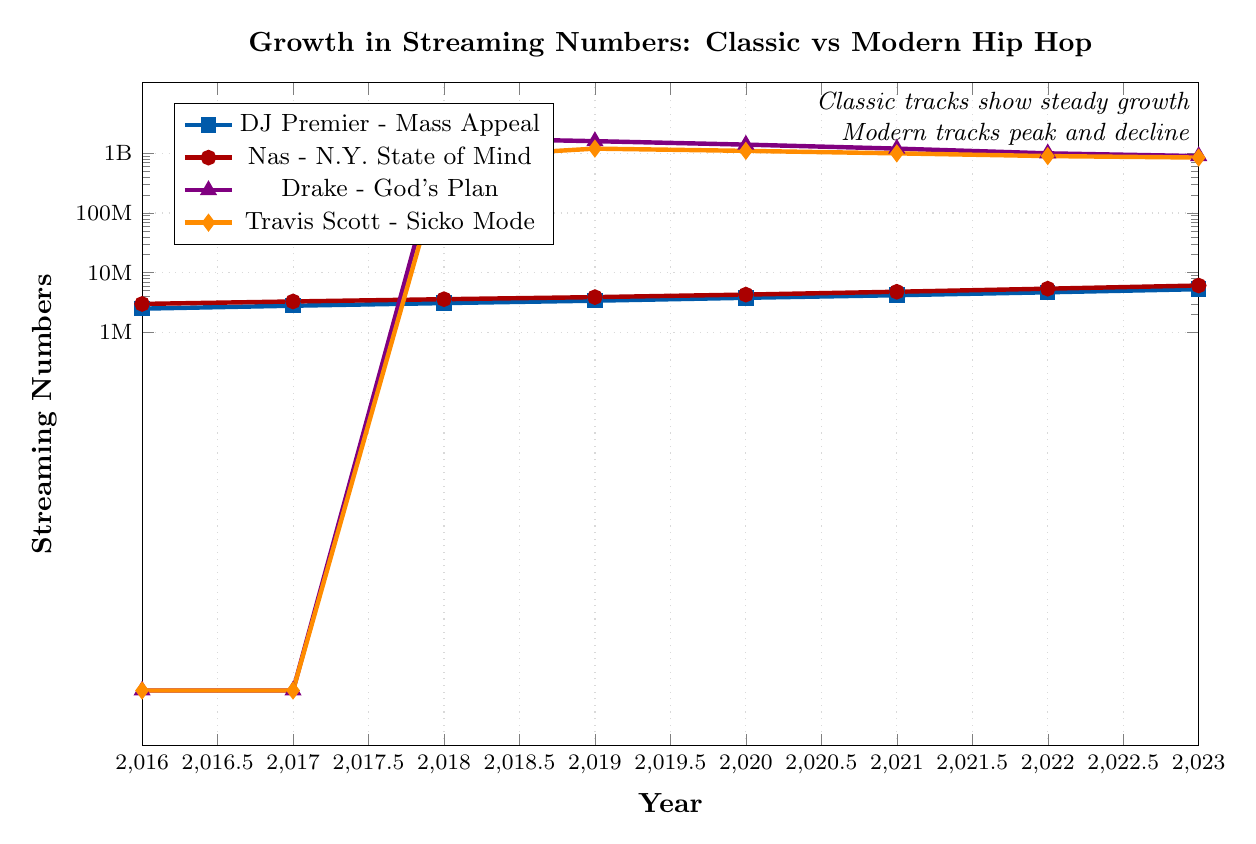What's the overall trend in streaming numbers for DJ Premier's "Mass Appeal" from 2016 to 2023? The figure shows a steadily increasing trend in the streaming numbers for "Mass Appeal" each year. The numbers start from 2,500,000 in 2016 and gradually increase to 5,300,000 by 2023.
Answer: Steady increase How do the streaming numbers for Nas's "N.Y. State of Mind" in 2023 compare to 2016? In 2016, the streaming numbers for "N.Y. State of Mind" were 3,000,000, while in 2023 they increased to 6,100,000. To compare, the numbers grew by 3,100,000 over this period.
Answer: Increased by 3,100,000 Which track had the highest streaming numbers in 2018, and what were they? In 2018, "God's Plan" by Drake had the highest streaming numbers, with 1,800,000,000 streams.
Answer: God's Plan by Drake with 1,800,000,000 streams Between 2018 and 2023, by how much did the streaming numbers for Travis Scott’s "Sicko Mode" decline? In 2018, "Sicko Mode" had 850,000,000 streams, and by 2023, it had 850,000,000 streams. The streaming numbers remained the same in 2018 and 2023.
Answer: Did not change Compare the growth trends of classic tracks (DJ Premier and Nas) and modern tracks (Drake and Travis Scott) between 2018 and 2023. What difference do you observe? Classic tracks show a steady increase in streaming numbers, with DJ Premier's numbers growing from 3,100,000 to 5,300,000 and Nas's from 3,600,000 to 6,100,000. Meanwhile, modern tracks show a decline over the same period, with Drake’s numbers dropping from 1,800,000,000 to 900,000,000 and Travis Scott’s from 850,000,000 to 850,000,000.
Answer: Classic tracks grow steadily, modern tracks decline By how much did "Nas - N.Y. State of Mind" streaming numbers increase each year on average from 2016 to 2023? The increase from 2016 to 2023 for "N.Y. State of Mind" is 3,100,000 (from 3,000,000 to 6,100,000). Dividing this by 7 years, the average annual increase is \( \frac{3,100,000}{7} \approx 442,857 \).
Answer: Approx. 442,857 Which track had the most significant drop in streaming numbers from 2018 to 2023? From the figure, "God's Plan" by Drake had the most significant drop, decreasing from 1,800,000,000 in 2018 to 900,000,000 in 2023.
Answer: God's Plan by Drake Rank the tracks in terms of their streaming numbers in 2023 from highest to lowest. In 2023, the streaming numbers are: Nas - 6,100,000, DJ Premier - 5,300,000, Drake - 900,000,000, and Travis Scott - 850,000,000. Ranking them gives: 1. Nas, 2. DJ Premier, 3. Drake, 4. Travis Scott.
Answer: 1. Nas, 2. DJ Premier, 3. Drake, 4. Travis Scott Compare the lowest streaming numbers observed for each track and identify which track holds the lowest value overall. In the figure, DJ Premier's "Mass Appeal" has the lowest streaming numbers in 2016 with 2,500,000 streams.
Answer: DJ Premier's Mass Appeal 